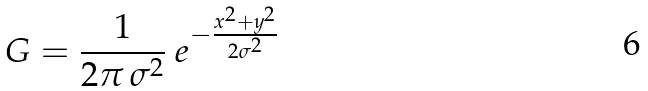<formula> <loc_0><loc_0><loc_500><loc_500>G = \frac { 1 } { 2 \pi \, \sigma ^ { 2 } } \ e ^ { - \frac { x ^ { 2 } + y ^ { 2 } } { 2 \sigma ^ { 2 } } }</formula> 